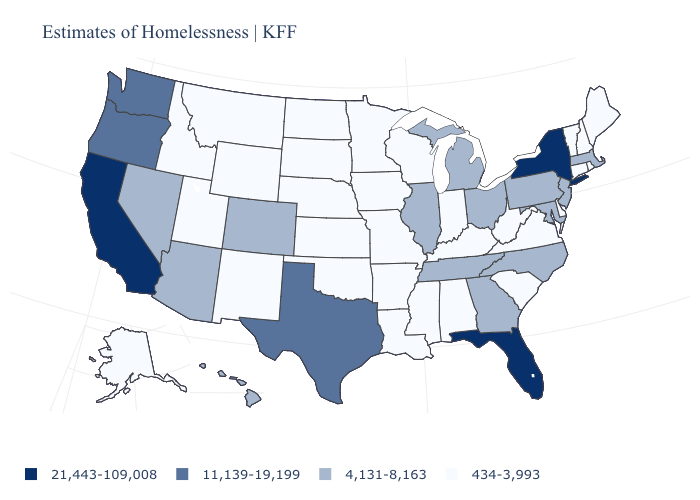Name the states that have a value in the range 4,131-8,163?
Answer briefly. Arizona, Colorado, Georgia, Hawaii, Illinois, Maryland, Massachusetts, Michigan, Nevada, New Jersey, North Carolina, Ohio, Pennsylvania, Tennessee. What is the value of Illinois?
Give a very brief answer. 4,131-8,163. Does West Virginia have a higher value than Wyoming?
Answer briefly. No. What is the value of Wisconsin?
Give a very brief answer. 434-3,993. Does the first symbol in the legend represent the smallest category?
Concise answer only. No. Does Utah have the highest value in the West?
Write a very short answer. No. What is the value of New York?
Concise answer only. 21,443-109,008. Name the states that have a value in the range 21,443-109,008?
Answer briefly. California, Florida, New York. What is the value of Mississippi?
Keep it brief. 434-3,993. What is the value of New Jersey?
Keep it brief. 4,131-8,163. Name the states that have a value in the range 11,139-19,199?
Quick response, please. Oregon, Texas, Washington. Name the states that have a value in the range 4,131-8,163?
Be succinct. Arizona, Colorado, Georgia, Hawaii, Illinois, Maryland, Massachusetts, Michigan, Nevada, New Jersey, North Carolina, Ohio, Pennsylvania, Tennessee. Does Idaho have a lower value than Montana?
Quick response, please. No. What is the value of Ohio?
Concise answer only. 4,131-8,163. Which states hav the highest value in the Northeast?
Quick response, please. New York. 